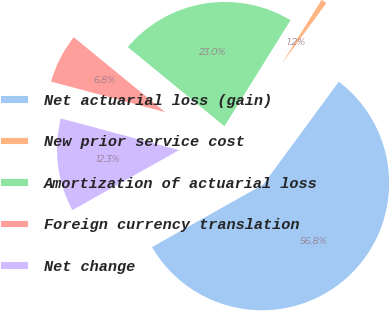Convert chart to OTSL. <chart><loc_0><loc_0><loc_500><loc_500><pie_chart><fcel>Net actuarial loss (gain)<fcel>New prior service cost<fcel>Amortization of actuarial loss<fcel>Foreign currency translation<fcel>Net change<nl><fcel>56.76%<fcel>1.21%<fcel>22.95%<fcel>6.76%<fcel>12.32%<nl></chart> 